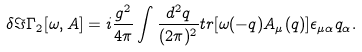Convert formula to latex. <formula><loc_0><loc_0><loc_500><loc_500>\delta \Im \Gamma _ { 2 } [ \omega , A ] = i \frac { g ^ { 2 } } { 4 \pi } \int \frac { d ^ { 2 } q } { ( 2 \pi ) ^ { 2 } } t r [ \omega ( - q ) A _ { \mu } ( q ) ] \epsilon _ { \mu \alpha } q _ { \alpha } .</formula> 